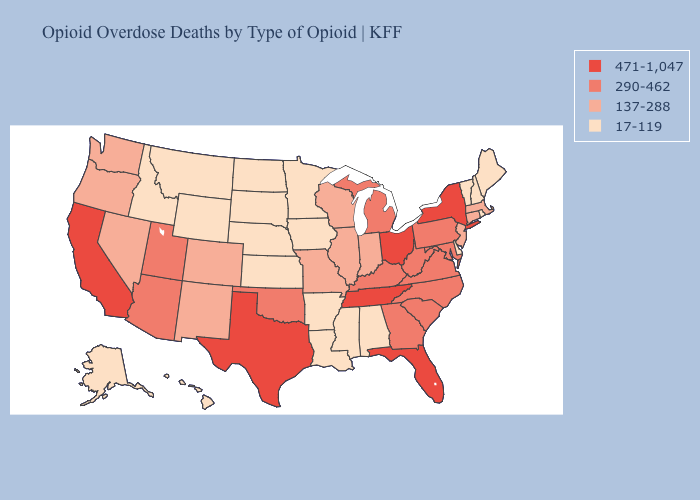Which states have the lowest value in the Northeast?
Write a very short answer. Maine, New Hampshire, Rhode Island, Vermont. Among the states that border Connecticut , which have the highest value?
Be succinct. New York. What is the lowest value in the Northeast?
Keep it brief. 17-119. What is the value of Kentucky?
Give a very brief answer. 290-462. What is the highest value in states that border Maryland?
Write a very short answer. 290-462. Name the states that have a value in the range 290-462?
Write a very short answer. Arizona, Georgia, Kentucky, Maryland, Michigan, North Carolina, Oklahoma, Pennsylvania, South Carolina, Utah, Virginia, West Virginia. Is the legend a continuous bar?
Write a very short answer. No. Among the states that border Vermont , which have the highest value?
Quick response, please. New York. Name the states that have a value in the range 17-119?
Answer briefly. Alabama, Alaska, Arkansas, Delaware, Hawaii, Idaho, Iowa, Kansas, Louisiana, Maine, Minnesota, Mississippi, Montana, Nebraska, New Hampshire, North Dakota, Rhode Island, South Dakota, Vermont, Wyoming. What is the lowest value in the MidWest?
Short answer required. 17-119. Does the first symbol in the legend represent the smallest category?
Write a very short answer. No. Does New Jersey have the same value as Idaho?
Concise answer only. No. Name the states that have a value in the range 137-288?
Give a very brief answer. Colorado, Connecticut, Illinois, Indiana, Massachusetts, Missouri, Nevada, New Jersey, New Mexico, Oregon, Washington, Wisconsin. Does the map have missing data?
Answer briefly. No. What is the value of Delaware?
Short answer required. 17-119. 